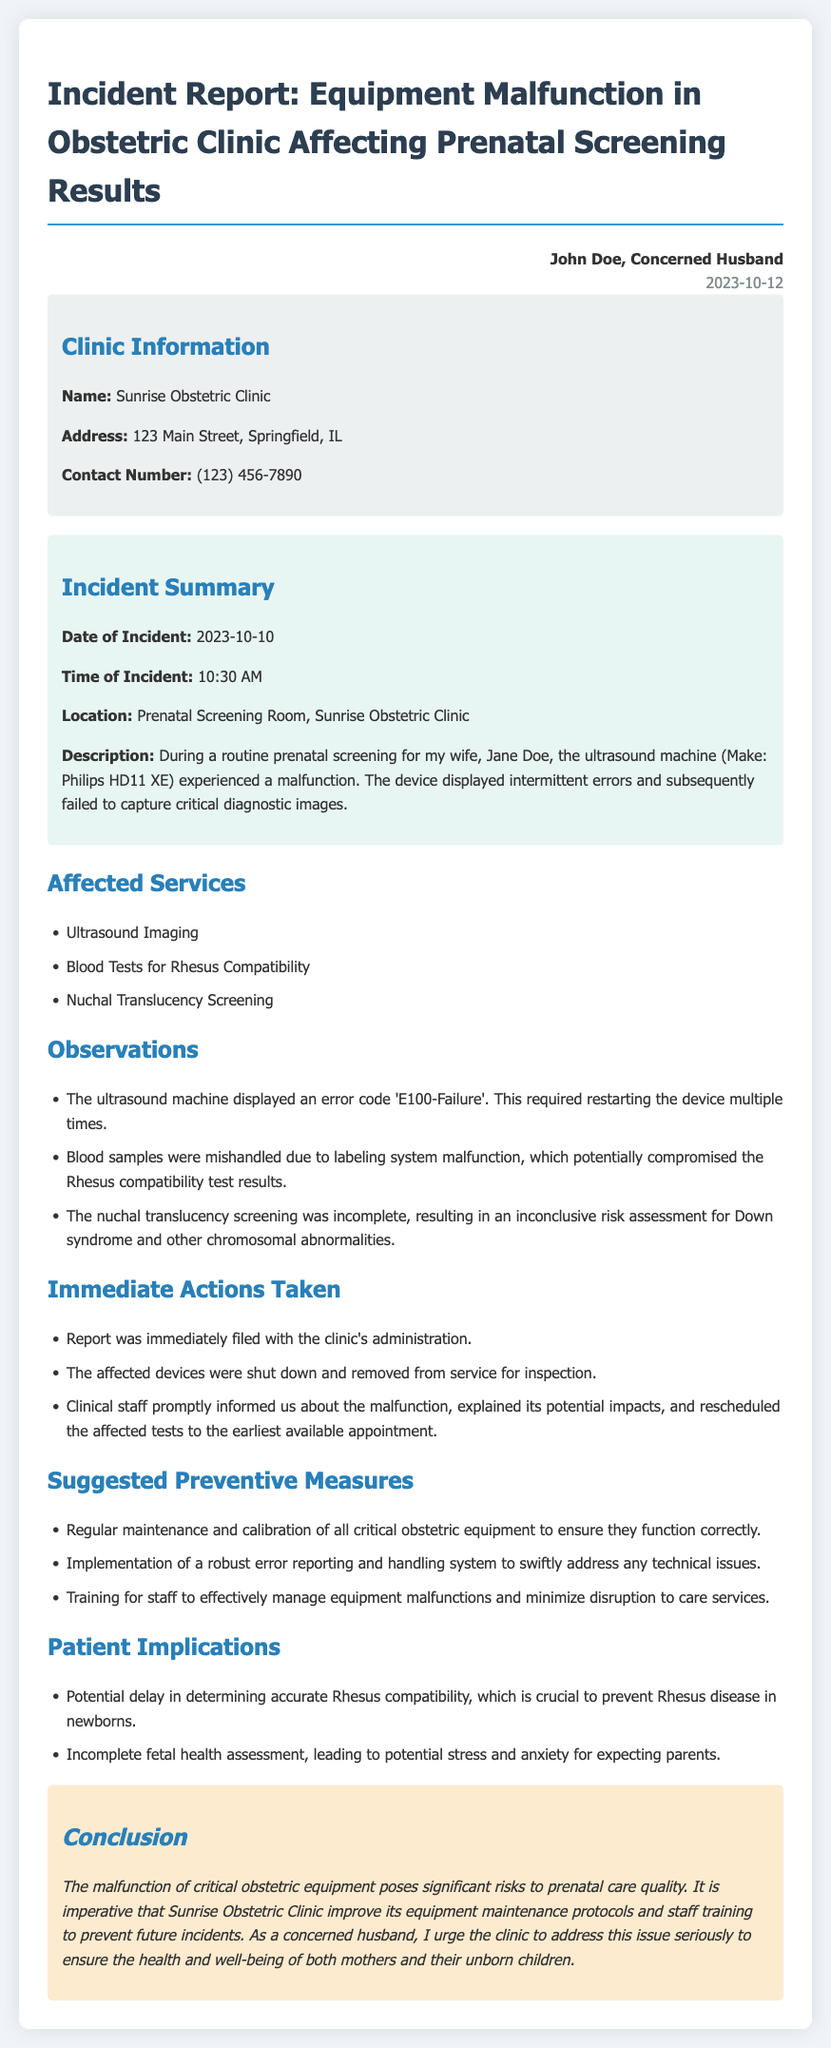what is the name of the clinic? The name of the clinic is stated in the clinic information section of the document.
Answer: Sunrise Obstetric Clinic what was the date of the incident? The date of the incident is mentioned in the incident summary section.
Answer: 2023-10-10 what error code was displayed by the ultrasound machine? The specific error code shown in the observations section provides this detail.
Answer: E100-Failure what critical service was affected by the equipment malfunction? This information is provided in the affected services section of the report.
Answer: Blood Tests for Rhesus Compatibility what were the immediate actions taken? The actions taken after the incident are listed under immediate actions taken.
Answer: Report was immediately filed with the clinic's administration what is a suggested preventive measure mentioned in the report? The report lists suggested preventive measures to address the issue.
Answer: Regular maintenance and calibration of all critical obstetric equipment what are the patient implications mentioned in the document? The implications for patients due to the incident are highlighted in the patient implications section.
Answer: Potential delay in determining accurate Rhesus compatibility who authored the incident report? The author of the report is noted at the top of the document.
Answer: John Doe, Concerned Husband 